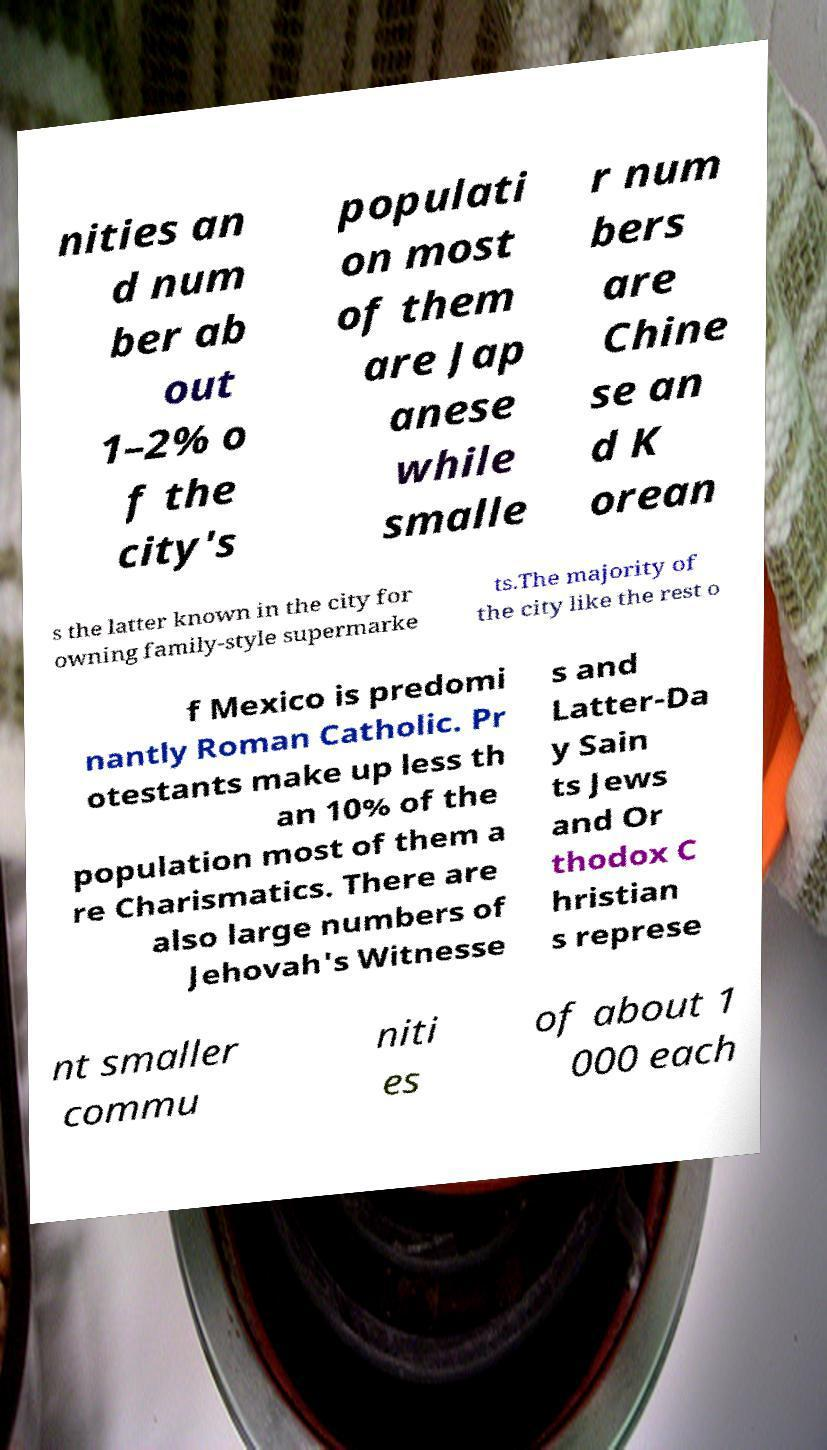Could you extract and type out the text from this image? nities an d num ber ab out 1–2% o f the city's populati on most of them are Jap anese while smalle r num bers are Chine se an d K orean s the latter known in the city for owning family-style supermarke ts.The majority of the city like the rest o f Mexico is predomi nantly Roman Catholic. Pr otestants make up less th an 10% of the population most of them a re Charismatics. There are also large numbers of Jehovah's Witnesse s and Latter-Da y Sain ts Jews and Or thodox C hristian s represe nt smaller commu niti es of about 1 000 each 